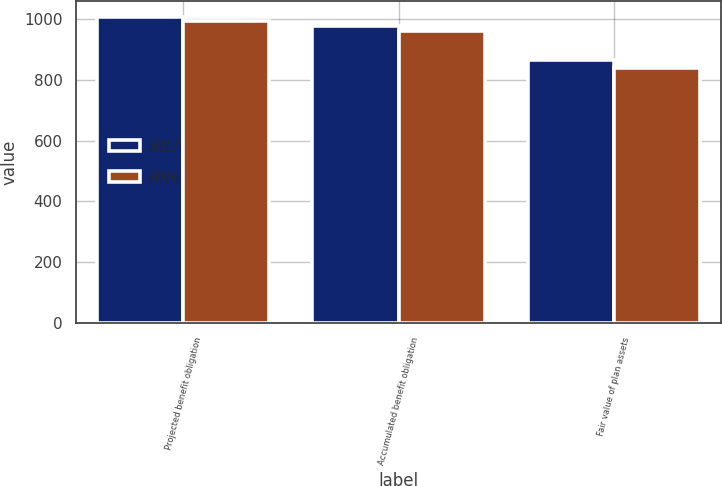Convert chart to OTSL. <chart><loc_0><loc_0><loc_500><loc_500><stacked_bar_chart><ecel><fcel>Projected benefit obligation<fcel>Accumulated benefit obligation<fcel>Fair value of plan assets<nl><fcel>2017<fcel>1007<fcel>976<fcel>864<nl><fcel>2016<fcel>993<fcel>960<fcel>837<nl></chart> 